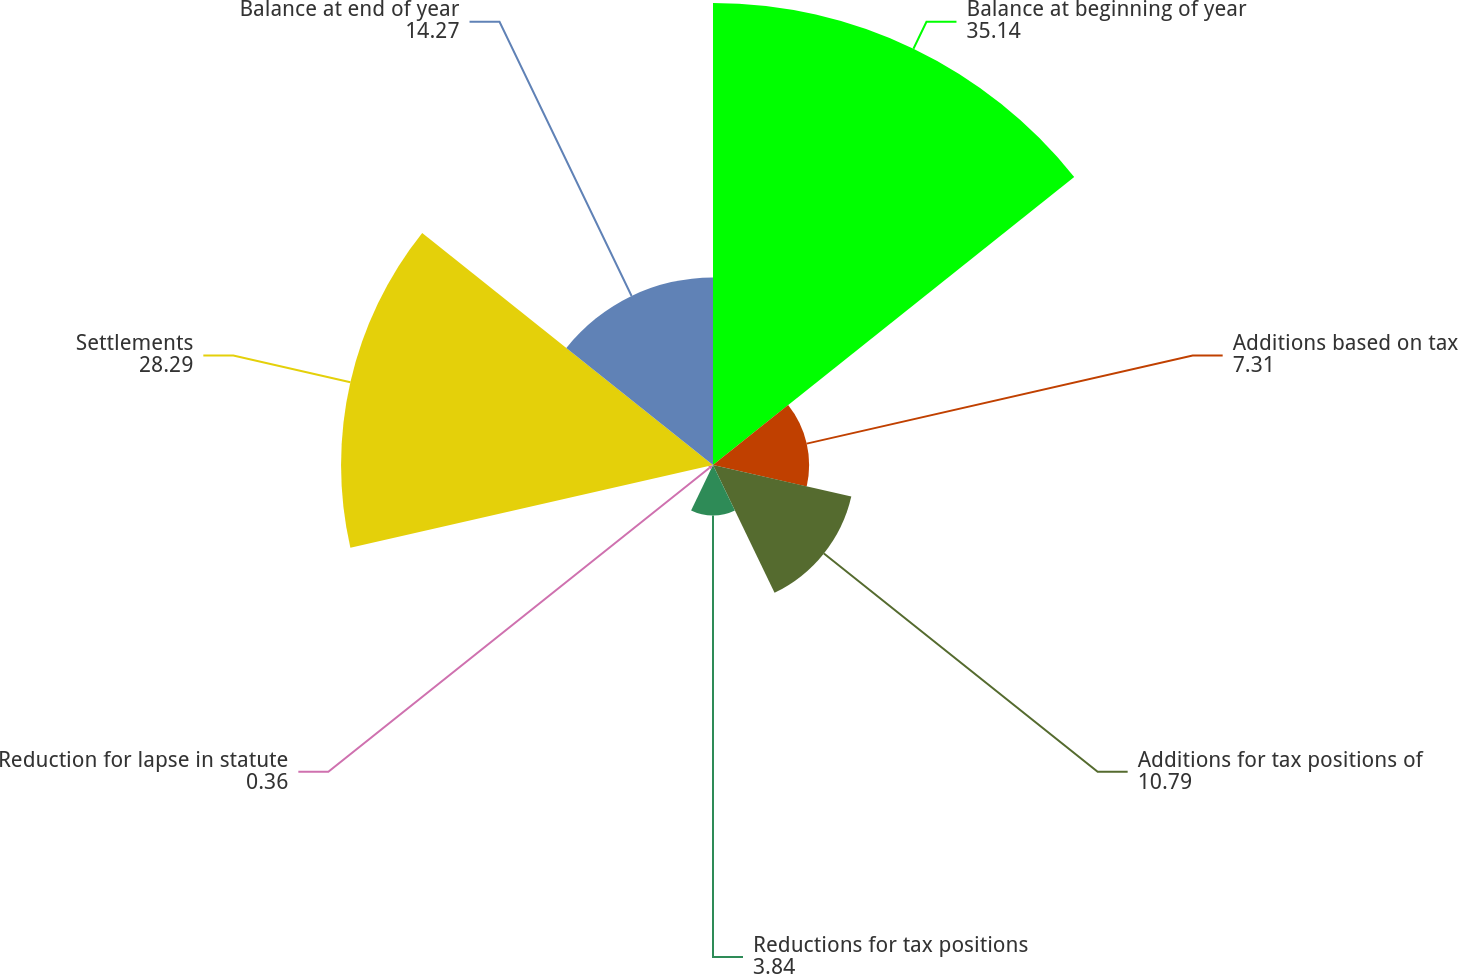Convert chart to OTSL. <chart><loc_0><loc_0><loc_500><loc_500><pie_chart><fcel>Balance at beginning of year<fcel>Additions based on tax<fcel>Additions for tax positions of<fcel>Reductions for tax positions<fcel>Reduction for lapse in statute<fcel>Settlements<fcel>Balance at end of year<nl><fcel>35.14%<fcel>7.31%<fcel>10.79%<fcel>3.84%<fcel>0.36%<fcel>28.29%<fcel>14.27%<nl></chart> 